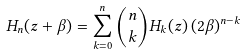<formula> <loc_0><loc_0><loc_500><loc_500>H _ { n } ( z + \beta ) = \sum _ { k = 0 } ^ { n } { n \choose k } H _ { k } ( z ) \, ( 2 \beta ) ^ { n - k }</formula> 